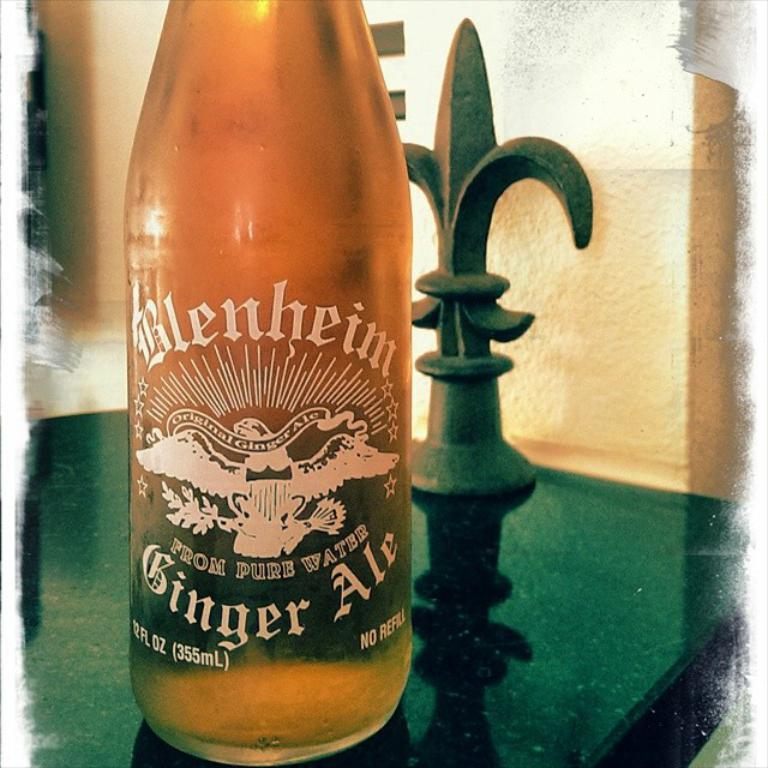What object is present in the image? There is a bottle in the image. Where is the bottle located? The bottle is on a table. What time is displayed on the receipt next to the bottle in the image? There is no receipt present in the image, so we cannot determine the time displayed on it. 